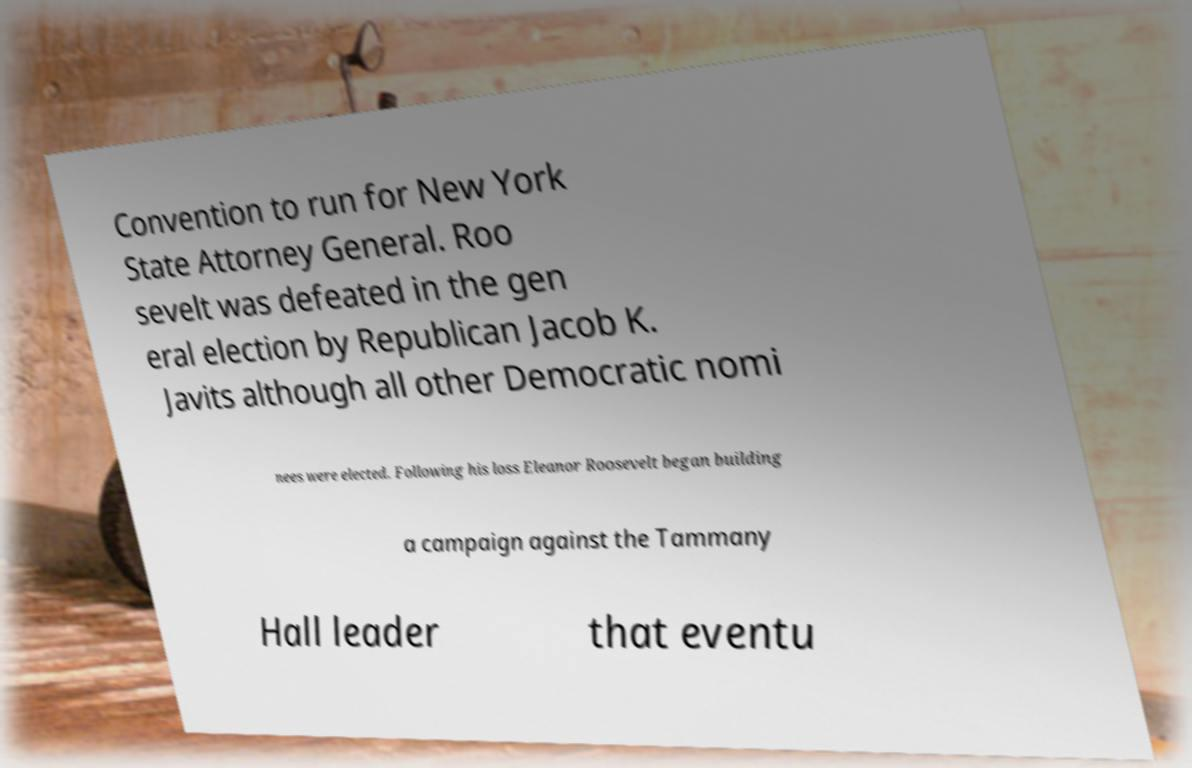I need the written content from this picture converted into text. Can you do that? Convention to run for New York State Attorney General. Roo sevelt was defeated in the gen eral election by Republican Jacob K. Javits although all other Democratic nomi nees were elected. Following his loss Eleanor Roosevelt began building a campaign against the Tammany Hall leader that eventu 